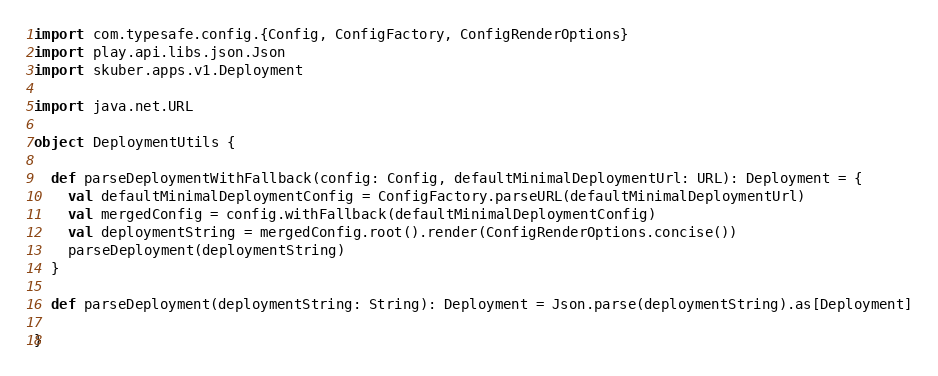<code> <loc_0><loc_0><loc_500><loc_500><_Scala_>
import com.typesafe.config.{Config, ConfigFactory, ConfigRenderOptions}
import play.api.libs.json.Json
import skuber.apps.v1.Deployment

import java.net.URL

object DeploymentUtils {

  def parseDeploymentWithFallback(config: Config, defaultMinimalDeploymentUrl: URL): Deployment = {
    val defaultMinimalDeploymentConfig = ConfigFactory.parseURL(defaultMinimalDeploymentUrl)
    val mergedConfig = config.withFallback(defaultMinimalDeploymentConfig)
    val deploymentString = mergedConfig.root().render(ConfigRenderOptions.concise())
    parseDeployment(deploymentString)
  }

  def parseDeployment(deploymentString: String): Deployment = Json.parse(deploymentString).as[Deployment]

}
</code> 